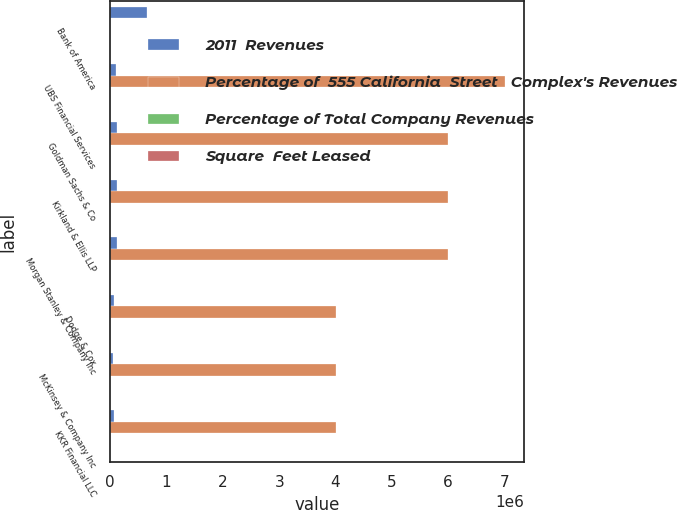<chart> <loc_0><loc_0><loc_500><loc_500><stacked_bar_chart><ecel><fcel>Bank of America<fcel>UBS Financial Services<fcel>Goldman Sachs & Co<fcel>Kirkland & Ellis LLP<fcel>Morgan Stanley & Company Inc<fcel>Dodge & Cox<fcel>McKinsey & Company Inc<fcel>KKR Financial LLC<nl><fcel>2011  Revenues<fcel>650000<fcel>106000<fcel>119000<fcel>125000<fcel>121000<fcel>62000<fcel>54000<fcel>59000<nl><fcel>Percentage of  555 California  Street   Complex's Revenues<fcel>34.3<fcel>7e+06<fcel>6e+06<fcel>6e+06<fcel>6e+06<fcel>4e+06<fcel>4e+06<fcel>4e+06<nl><fcel>Percentage of Total Company Revenues<fcel>34.3<fcel>6.8<fcel>6.4<fcel>6<fcel>5.8<fcel>3.9<fcel>3.8<fcel>3.5<nl><fcel>Square  Feet Leased<fcel>1.2<fcel>0.2<fcel>0.2<fcel>0.2<fcel>0.2<fcel>0.1<fcel>0.1<fcel>0.1<nl></chart> 